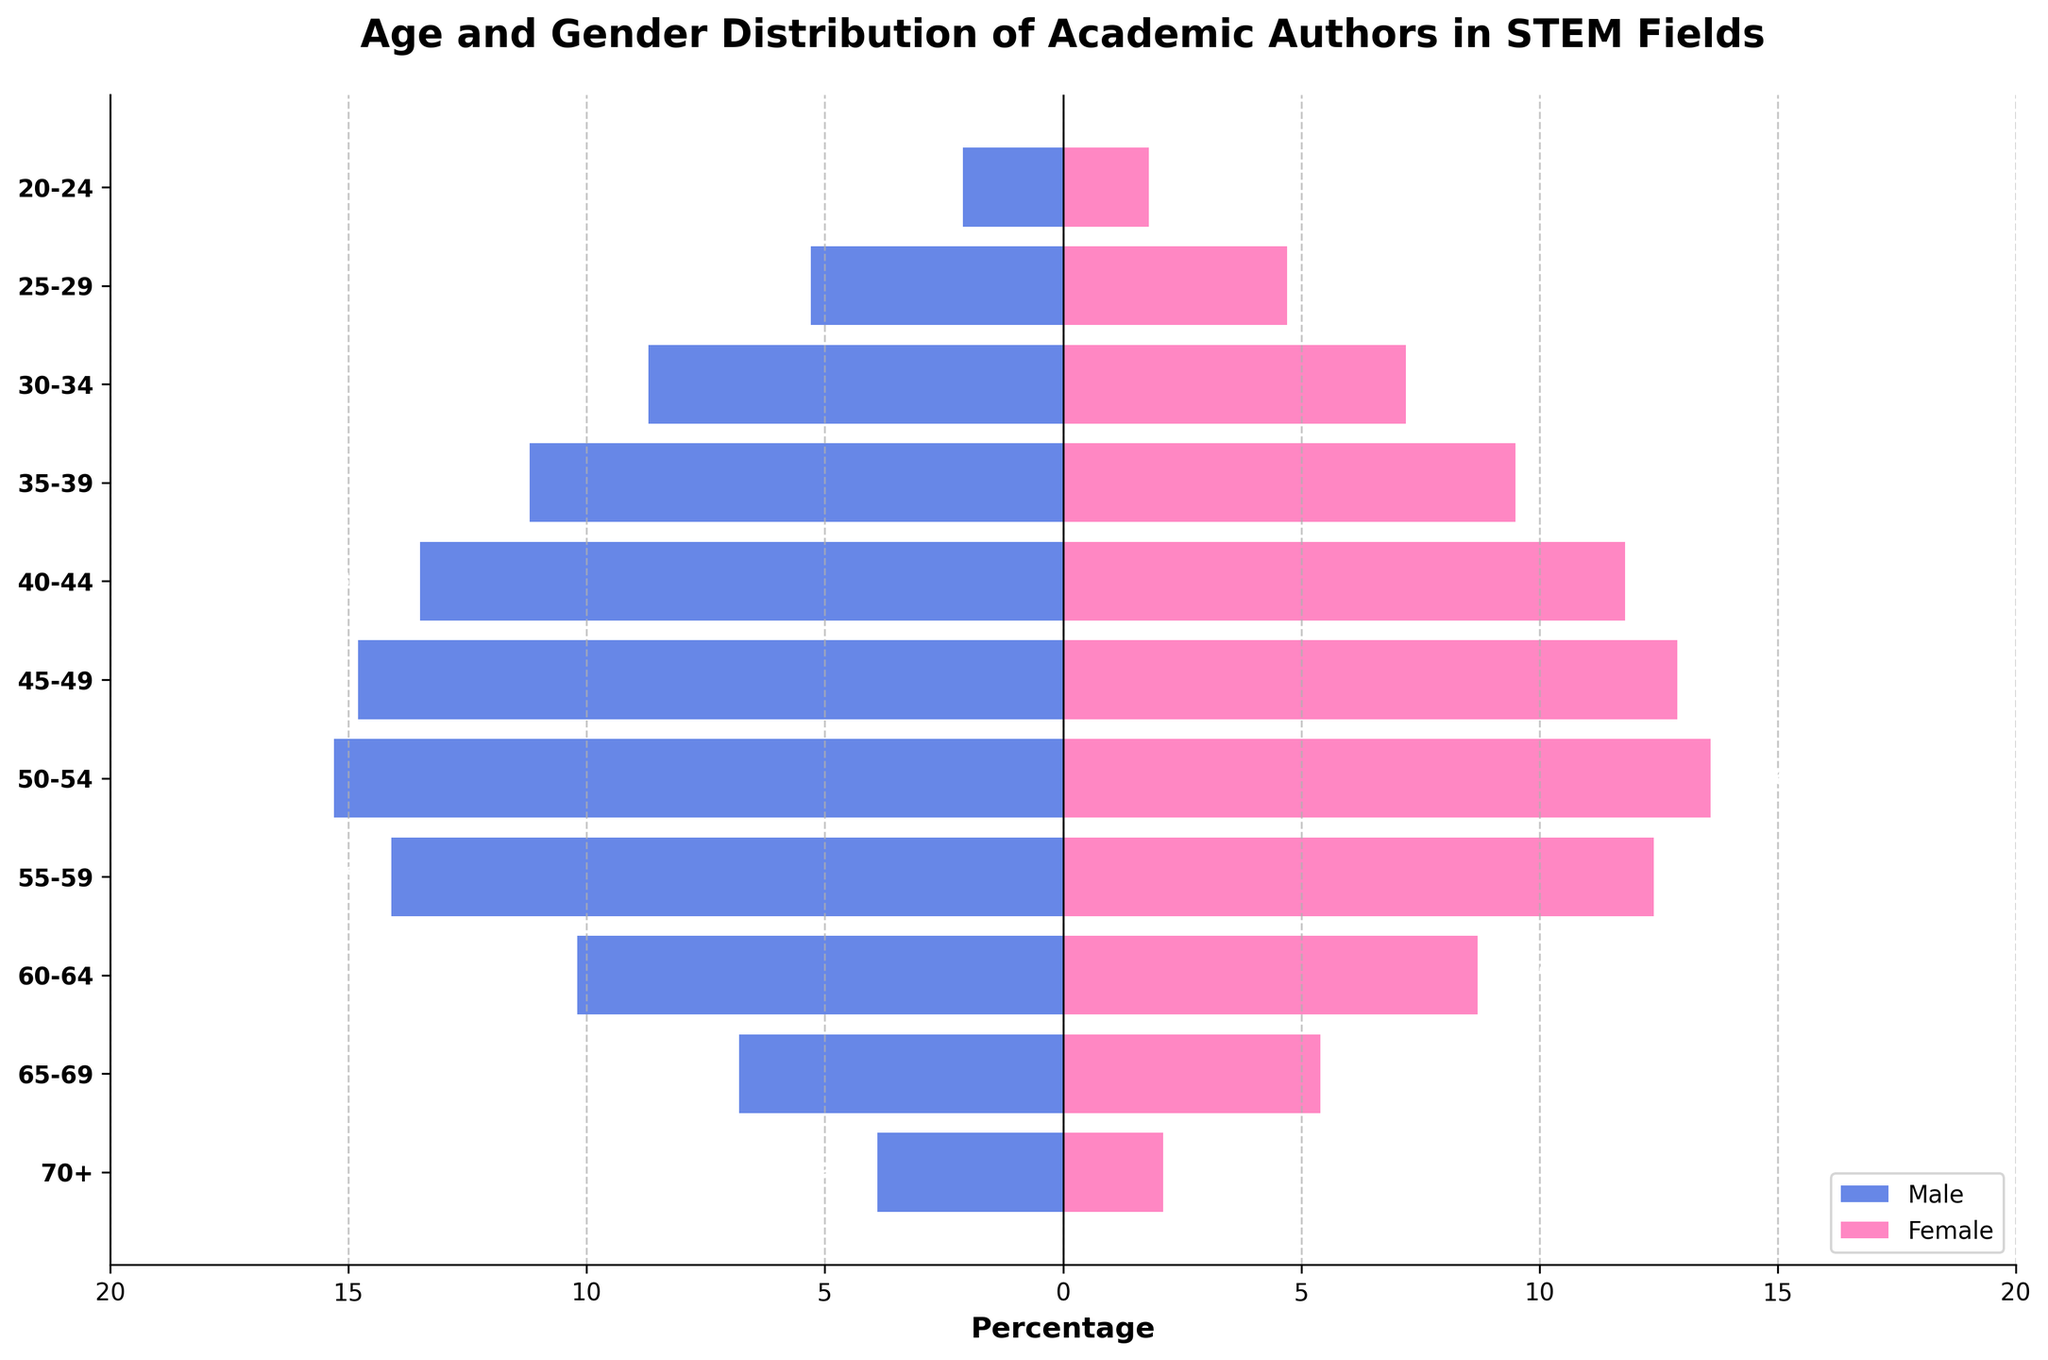What is the title of the figure? The title is usually found at the top of the figure. Here, it says "Age and Gender Distribution of Academic Authors in STEM Fields".
Answer: Age and Gender Distribution of Academic Authors in STEM Fields What are the colors used for male and female bars in the population pyramid? The colors can be seen in the figure legend or by looking at the bars. Males are represented in blue and females in pink.
Answer: Blue for Male, Pink for Female Which age group has the highest percentage of male academic authors? By examining the lengths of the blue bars, the longest one corresponds to the age group 50-54 with a value of 15.3%.
Answer: 50-54 What is the difference in percentage between male and female authors in the 45-49 age group? The male percentage for 45-49 is 14.8%, and the female percentage is 12.9%. Subtracting these gives 14.8% - 12.9% = 1.9%.
Answer: 1.9% At which age group do male and female percentages start to decrease significantly? Observing the lengths of bars, both male and female percentages start to decrease after the age group 55-59.
Answer: 55-59 How does the gender distribution compare for authors aged 70 and above? The blue and pink bars for the 70+ age group show that males are 3.9% and females are 2.1%. Therefore, males are more prevalent in this age group.
Answer: Males: 3.9%, Females: 2.1% What is the total percentage of female academic authors in the age range 30-44? Summing the percentages for the age groups 30-34, 35-39, and 40-44 gives 7.2% + 9.5% + 11.8% = 28.5%.
Answer: 28.5% Is there any age group where the percentage of female authors is higher than male authors? By comparing the lengths of blue and pink bars for each age group, there is no age group where the pink bar (female) exceeds the blue bar (male).
Answer: No What is the combined percentage of male and female authors aged 25-29? Adding the percentages for male (5.3%) and female (4.7%) gives 5.3% + 4.7% = 10.0%.
Answer: 10.0% In which age group is the percentage of female academic authors the lowest? The shortest pink bar corresponds to the age group 70+, with a value of 2.1%.
Answer: 70+ 